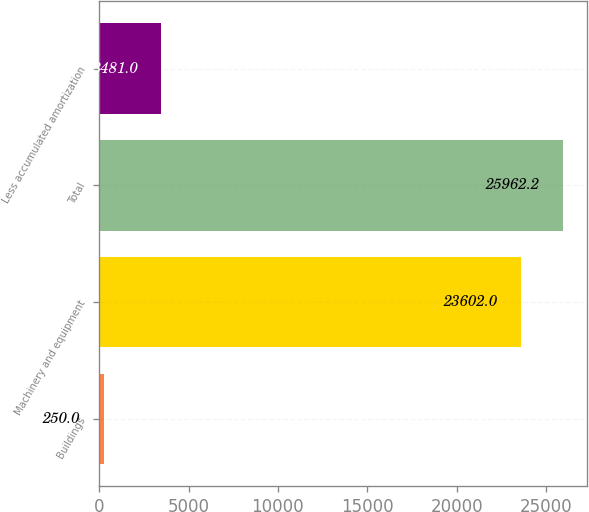Convert chart to OTSL. <chart><loc_0><loc_0><loc_500><loc_500><bar_chart><fcel>Buildings<fcel>Machinery and equipment<fcel>Total<fcel>Less accumulated amortization<nl><fcel>250<fcel>23602<fcel>25962.2<fcel>3481<nl></chart> 